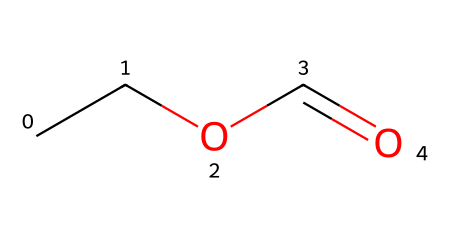What is the main functional group in this molecule? The SMILES representation indicates the presence of a carbonyl group (C=O) and an oxygen atom connected to a carbon chain (ethyl), which defines it as an ester.
Answer: ester How many carbon atoms are present in ethyl formate? Analyzing the structure, there are two carbon atoms in the ethyl part (C2) and one carbon in the carbonyl (formate), totaling three carbon atoms.
Answer: three What type of odor is associated with ethyl formate? Ethyl formate is known for its fruit-like odor, which is characteristic of several esters, often used in flavorings.
Answer: fruit-like How many hydrogen atoms are in ethyl formate? In the ethyl group (C2H5), there are five hydrogen atoms, and there are also two hydrogen atoms from the formate part (COO–), making seven total.
Answer: seven Does ethyl formate have any specific applications? Ethyl formate is primarily used as a flavoring agent in food products and beverages due to its pleasant aroma.
Answer: flavoring agent What is the molecular formula of ethyl formate? From the SMILES representation, we can deduce that the molecular formula includes three carbon atoms, six hydrogen atoms, and two oxygen atoms, leading to C3H6O2.
Answer: C3H6O2 